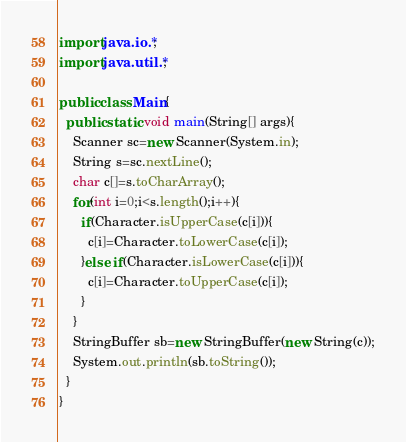Convert code to text. <code><loc_0><loc_0><loc_500><loc_500><_Java_>import java.io.*;
import java.util.*;

public class Main{
  public static void main(String[] args){
    Scanner sc=new Scanner(System.in);
    String s=sc.nextLine();
    char c[]=s.toCharArray();
    for(int i=0;i<s.length();i++){
      if(Character.isUpperCase(c[i])){
        c[i]=Character.toLowerCase(c[i]);
      }else if(Character.isLowerCase(c[i])){
        c[i]=Character.toUpperCase(c[i]);
      }
    }
    StringBuffer sb=new StringBuffer(new String(c));
    System.out.println(sb.toString());
  }
}

</code> 